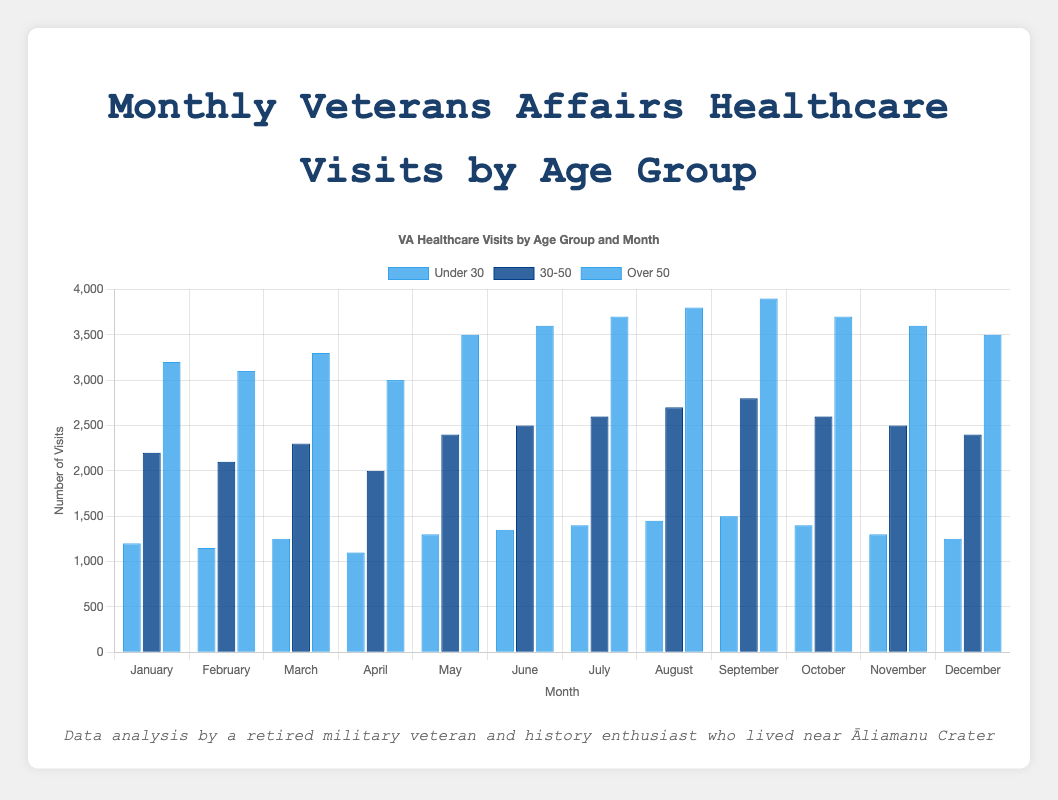Which age group has the highest number of visits in September? To determine this, compare the visits for each age group in September. "Under 30" has 1500 visits, "30-50" has 2800 visits, and "Over 50" has 3900 visits. The highest number is 3900 from the "Over 50" group.
Answer: Over 50 What is the difference in the number of visits between the "30-50" and "Over 50" age groups in June? Subtract the visits of the "30-50" group from the "Over 50" group in June. For "30-50", the visits are 2500, and for "Over 50", the visits are 3600. The difference is 3600 - 2500 = 1100.
Answer: 1100 Which month had the lowest number of visits for the "Under 30" age group? Review the visits for each month for the "Under 30" group. The lowest number is in April with 1100 visits.
Answer: April What is the total number of visits by the "Under 30" age group in the first quarter (January to March)? Sum the visits of January, February, and March for the "Under 30" group. 1200 (January) + 1150 (February) + 1250 (March) = 3600.
Answer: 3600 Which group showed the greatest increase in visits from January to December? For each age group, subtract January visits from December visits. "Under 30": 1250 - 1200 = 50, "30-50": 2400 - 2200 = 200, "Over 50": 3500 - 3200 = 300. The "Over 50" group has the greatest increase at 300 visits.
Answer: Over 50 Which age group had more visits in February, the "Under 30" group or the "30-50" group? Compare February visits between the two age groups. "Under 30" has 1150 visits, and "30-50" has 2100 visits. The "30-50" group had more visits.
Answer: 30-50 In which month did the "30-50" age group have the same number of visits as the "Over 50" age group did in November? The "Over 50" group had 3600 visits in November. Check each month for the "30-50" group to find a match. In August, the "30-50" group had 2700 visits, not a match. Similarly, the other months don't match until checking the November of the same group for 2500 which also does not align. No exact match found; hence, there's no same count by cross-refencing.
Answer: None What was the average number of monthly visits by the "30-50" age group? Sum all visits from January to December for the "30-50" group and divide by 12. (2200 + 2100 + 2300 + 2000 + 2400 + 2500 + 2600 + 2700 + 2800 + 2600 + 2500 + 2400) = 29100. Average = 29100 / 12 = 2425.
Answer: 2425 How many months did the "Over 50" age group have more than 3500 visits? Count the months where the "Over 50" group had visits greater than 3500. These are: June (3600), July (3700), August (3800), September (3900), October (3700), November (3600), and December (3500 is not more). Total = 6 months.
Answer: 6 